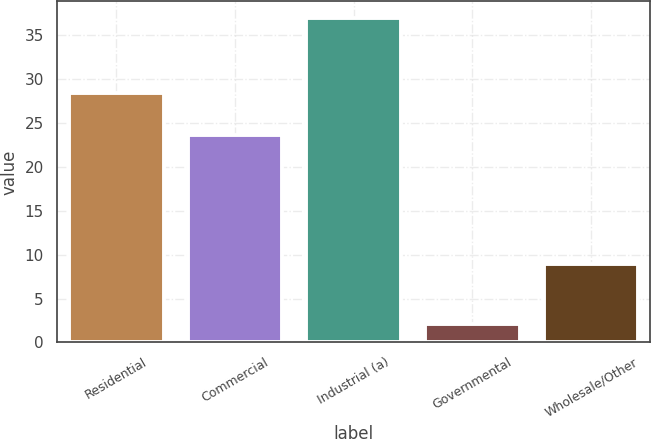Convert chart. <chart><loc_0><loc_0><loc_500><loc_500><bar_chart><fcel>Residential<fcel>Commercial<fcel>Industrial (a)<fcel>Governmental<fcel>Wholesale/Other<nl><fcel>28.4<fcel>23.6<fcel>37<fcel>2.1<fcel>8.9<nl></chart> 